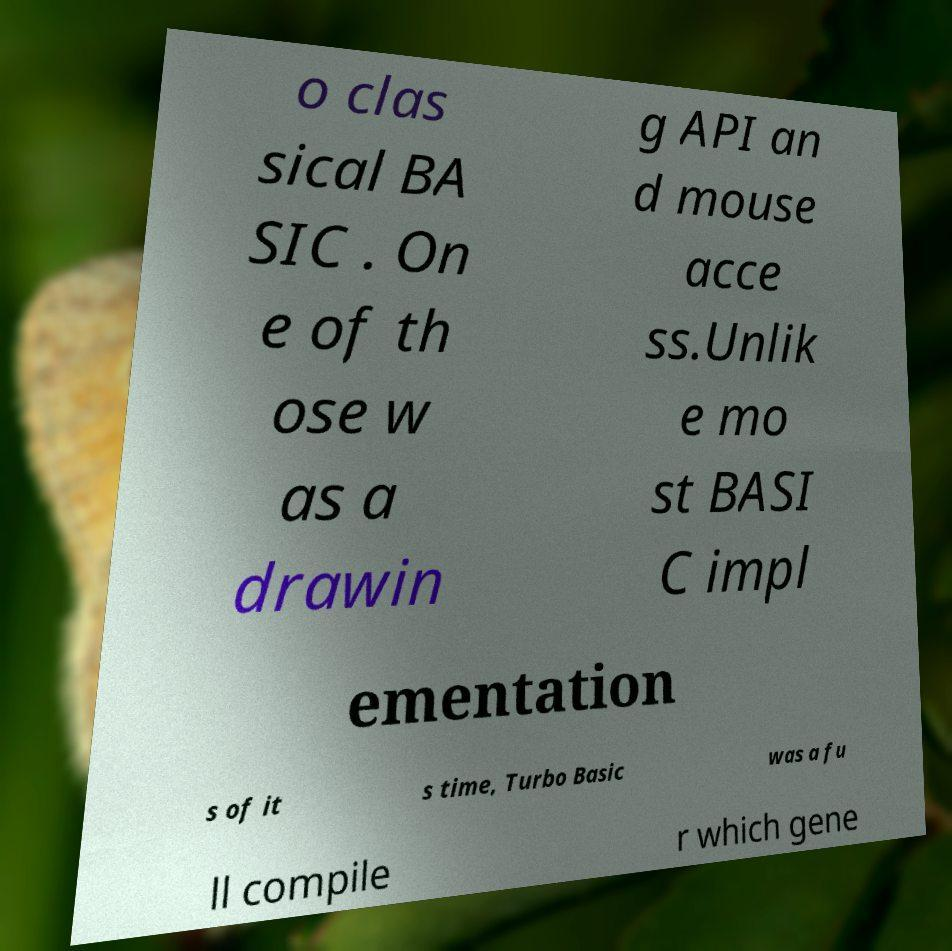What messages or text are displayed in this image? I need them in a readable, typed format. o clas sical BA SIC . On e of th ose w as a drawin g API an d mouse acce ss.Unlik e mo st BASI C impl ementation s of it s time, Turbo Basic was a fu ll compile r which gene 